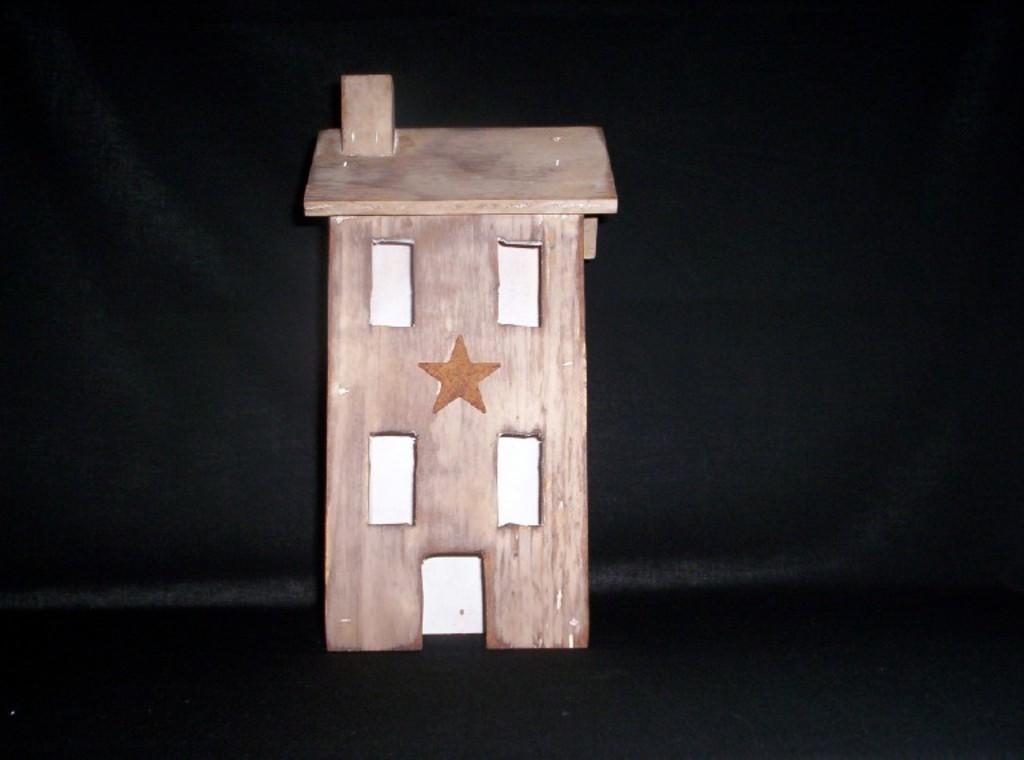Could you give a brief overview of what you see in this image? In this image we can see a toy house with some windows and a star on it which is placed on the surface. 